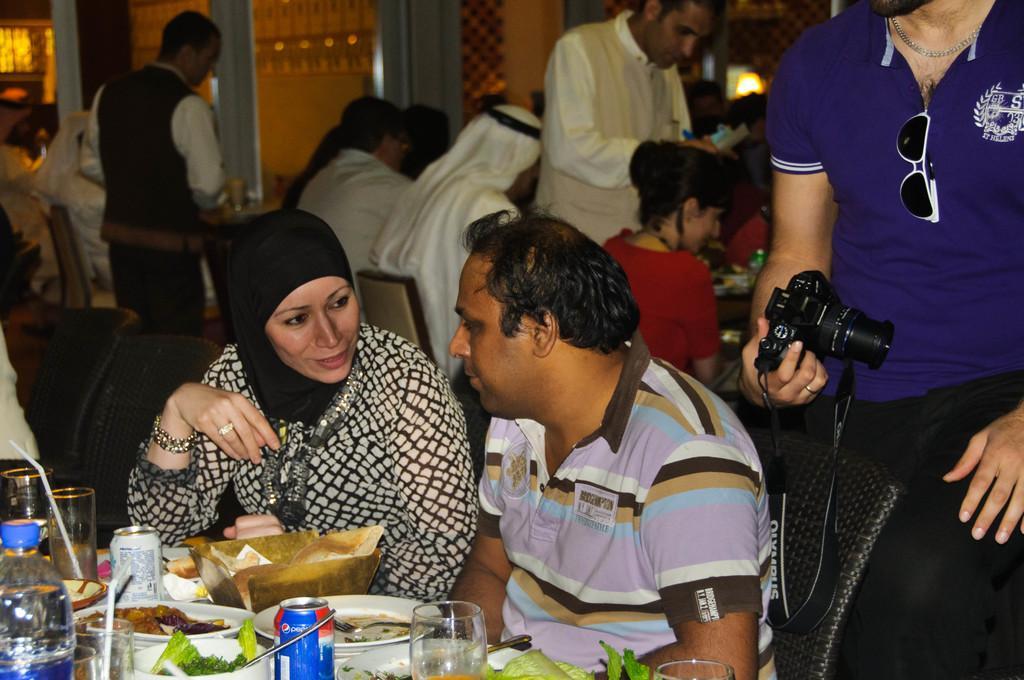Please provide a concise description of this image. In the center we can see two persons were sitting on the chair around the table. On table there is a food items and on the right we can see one person standing and holding camera. And coming to background we can see few persons were standing and sitting on the chair. 